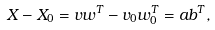Convert formula to latex. <formula><loc_0><loc_0><loc_500><loc_500>X - X _ { 0 } = v w ^ { T } - v _ { 0 } w _ { 0 } ^ { T } = a b ^ { T } ,</formula> 